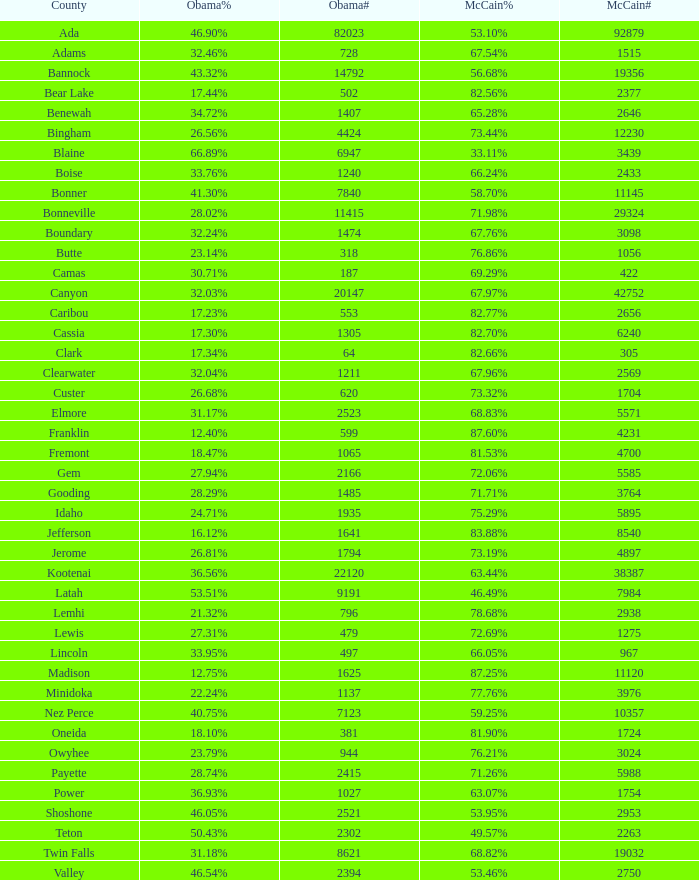For Gem County, what was the Obama vote percentage? 27.94%. 